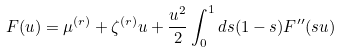<formula> <loc_0><loc_0><loc_500><loc_500>F ( u ) = \mu ^ { ( r ) } + \zeta ^ { ( r ) } u + \frac { u ^ { 2 } } { 2 } \int _ { 0 } ^ { 1 } d s ( 1 - s ) F ^ { \prime \prime } ( s u )</formula> 